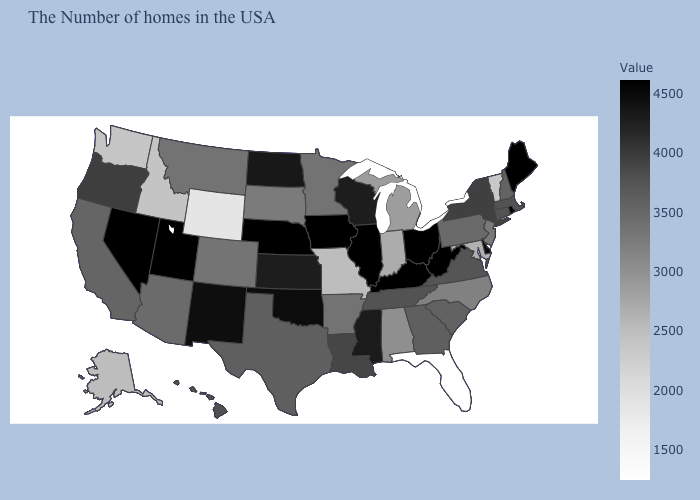Which states hav the highest value in the West?
Short answer required. Utah, Nevada. Which states have the highest value in the USA?
Answer briefly. Maine, Rhode Island, West Virginia, Ohio, Kentucky, Illinois, Iowa, Nebraska, Utah, Nevada. Among the states that border Arkansas , does Texas have the highest value?
Write a very short answer. No. 